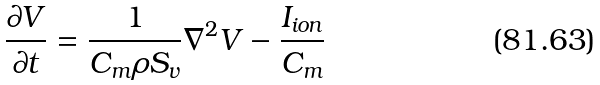Convert formula to latex. <formula><loc_0><loc_0><loc_500><loc_500>\frac { \partial V } { \partial t } = \frac { 1 } { C _ { m } \rho S _ { v } } \nabla ^ { 2 } V - \frac { I _ { i o n } } { C _ { m } }</formula> 